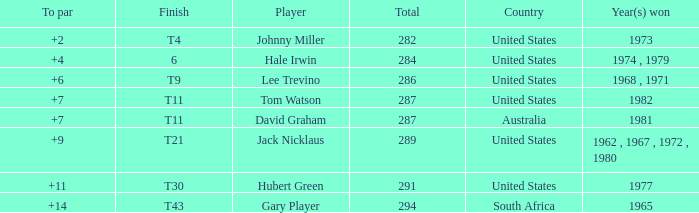WHAT IS THE TOTAL THAT HAS A WIN IN 1982? 287.0. 